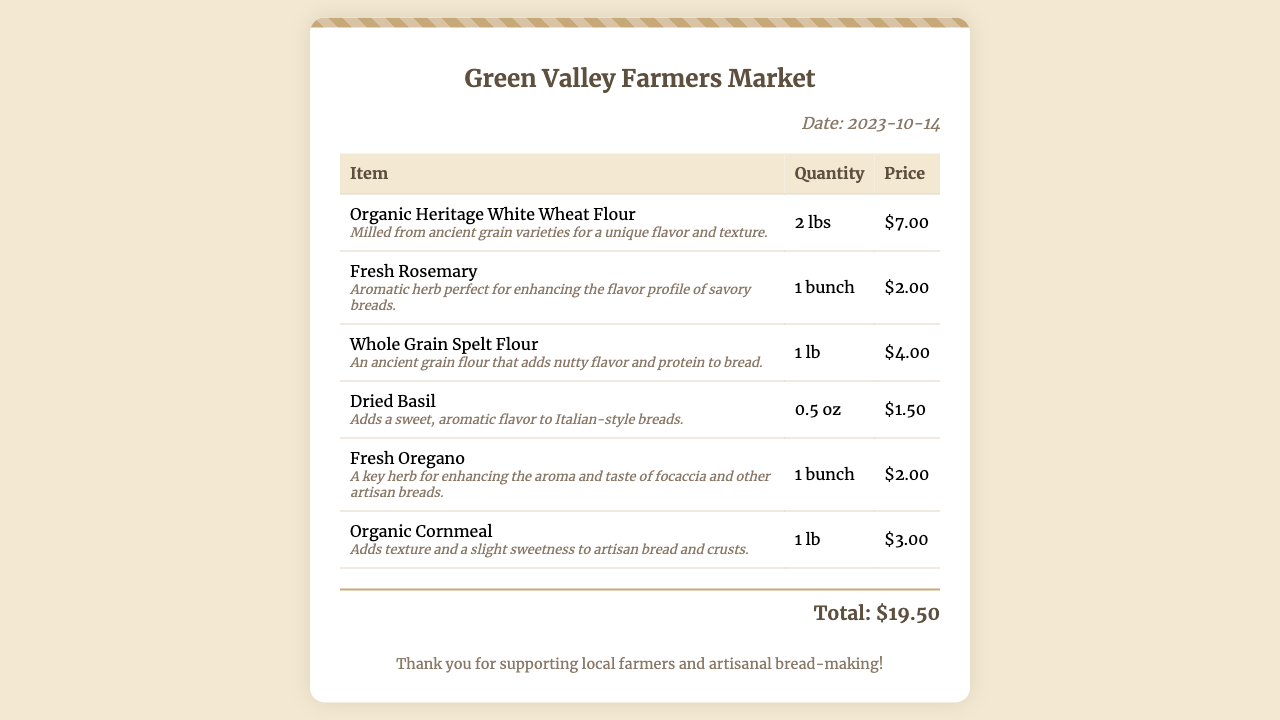what is the date of the receipt? The date of the receipt is clearly stated in the document.
Answer: 2023-10-14 how many pounds of Organic Heritage White Wheat Flour were purchased? The quantity of Organic Heritage White Wheat Flour is specified in the item details.
Answer: 2 lbs what is the price of Whole Grain Spelt Flour? The price for Whole Grain Spelt Flour is listed next to the item in the document.
Answer: $4.00 which herb is described as perfect for enhancing the flavor profile of savory breads? The document mentions specific herbs and their uses, highlighting the one for savory breads.
Answer: Fresh Rosemary how much did the total purchase cost? The total cost of all items is provided at the bottom of the receipt.
Answer: $19.50 which ingredient adds a sweet, aromatic flavor to Italian-style breads? The document specifies the ingredient that enhances the flavor of Italian breads.
Answer: Dried Basil is Organic Cornmeal included in the receipt? The presence of Organic Cornmeal can be checked in the item list.
Answer: Yes what type of wheat flour is mentioned as milled from ancient grain varieties? The document specifies the type of flour made from ancient grains.
Answer: Organic Heritage White Wheat Flour 